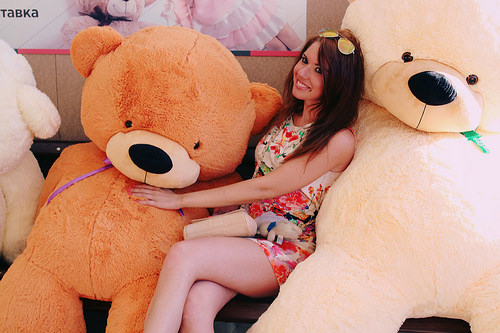<image>
Can you confirm if the brown teddy is to the right of the white teddy? No. The brown teddy is not to the right of the white teddy. The horizontal positioning shows a different relationship. Is the teddy bear under the woman? No. The teddy bear is not positioned under the woman. The vertical relationship between these objects is different. Is the woman to the left of the stuffed bear? No. The woman is not to the left of the stuffed bear. From this viewpoint, they have a different horizontal relationship. 